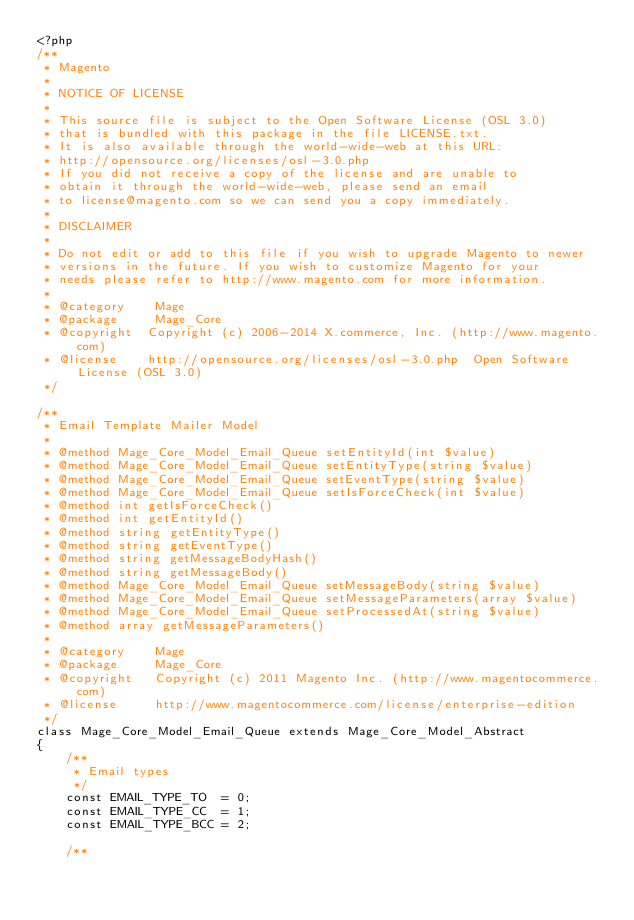Convert code to text. <code><loc_0><loc_0><loc_500><loc_500><_PHP_><?php
/**
 * Magento
 *
 * NOTICE OF LICENSE
 *
 * This source file is subject to the Open Software License (OSL 3.0)
 * that is bundled with this package in the file LICENSE.txt.
 * It is also available through the world-wide-web at this URL:
 * http://opensource.org/licenses/osl-3.0.php
 * If you did not receive a copy of the license and are unable to
 * obtain it through the world-wide-web, please send an email
 * to license@magento.com so we can send you a copy immediately.
 *
 * DISCLAIMER
 *
 * Do not edit or add to this file if you wish to upgrade Magento to newer
 * versions in the future. If you wish to customize Magento for your
 * needs please refer to http://www.magento.com for more information.
 *
 * @category    Mage
 * @package     Mage_Core
 * @copyright  Copyright (c) 2006-2014 X.commerce, Inc. (http://www.magento.com)
 * @license    http://opensource.org/licenses/osl-3.0.php  Open Software License (OSL 3.0)
 */

/**
 * Email Template Mailer Model
 *
 * @method Mage_Core_Model_Email_Queue setEntityId(int $value)
 * @method Mage_Core_Model_Email_Queue setEntityType(string $value)
 * @method Mage_Core_Model_Email_Queue setEventType(string $value)
 * @method Mage_Core_Model_Email_Queue setIsForceCheck(int $value)
 * @method int getIsForceCheck()
 * @method int getEntityId()
 * @method string getEntityType()
 * @method string getEventType()
 * @method string getMessageBodyHash()
 * @method string getMessageBody()
 * @method Mage_Core_Model_Email_Queue setMessageBody(string $value)
 * @method Mage_Core_Model_Email_Queue setMessageParameters(array $value)
 * @method Mage_Core_Model_Email_Queue setProcessedAt(string $value)
 * @method array getMessageParameters()
 *
 * @category    Mage
 * @package     Mage_Core
 * @copyright   Copyright (c) 2011 Magento Inc. (http://www.magentocommerce.com)
 * @license     http://www.magentocommerce.com/license/enterprise-edition
 */
class Mage_Core_Model_Email_Queue extends Mage_Core_Model_Abstract
{
    /**
     * Email types
     */
    const EMAIL_TYPE_TO  = 0;
    const EMAIL_TYPE_CC  = 1;
    const EMAIL_TYPE_BCC = 2;

    /**</code> 